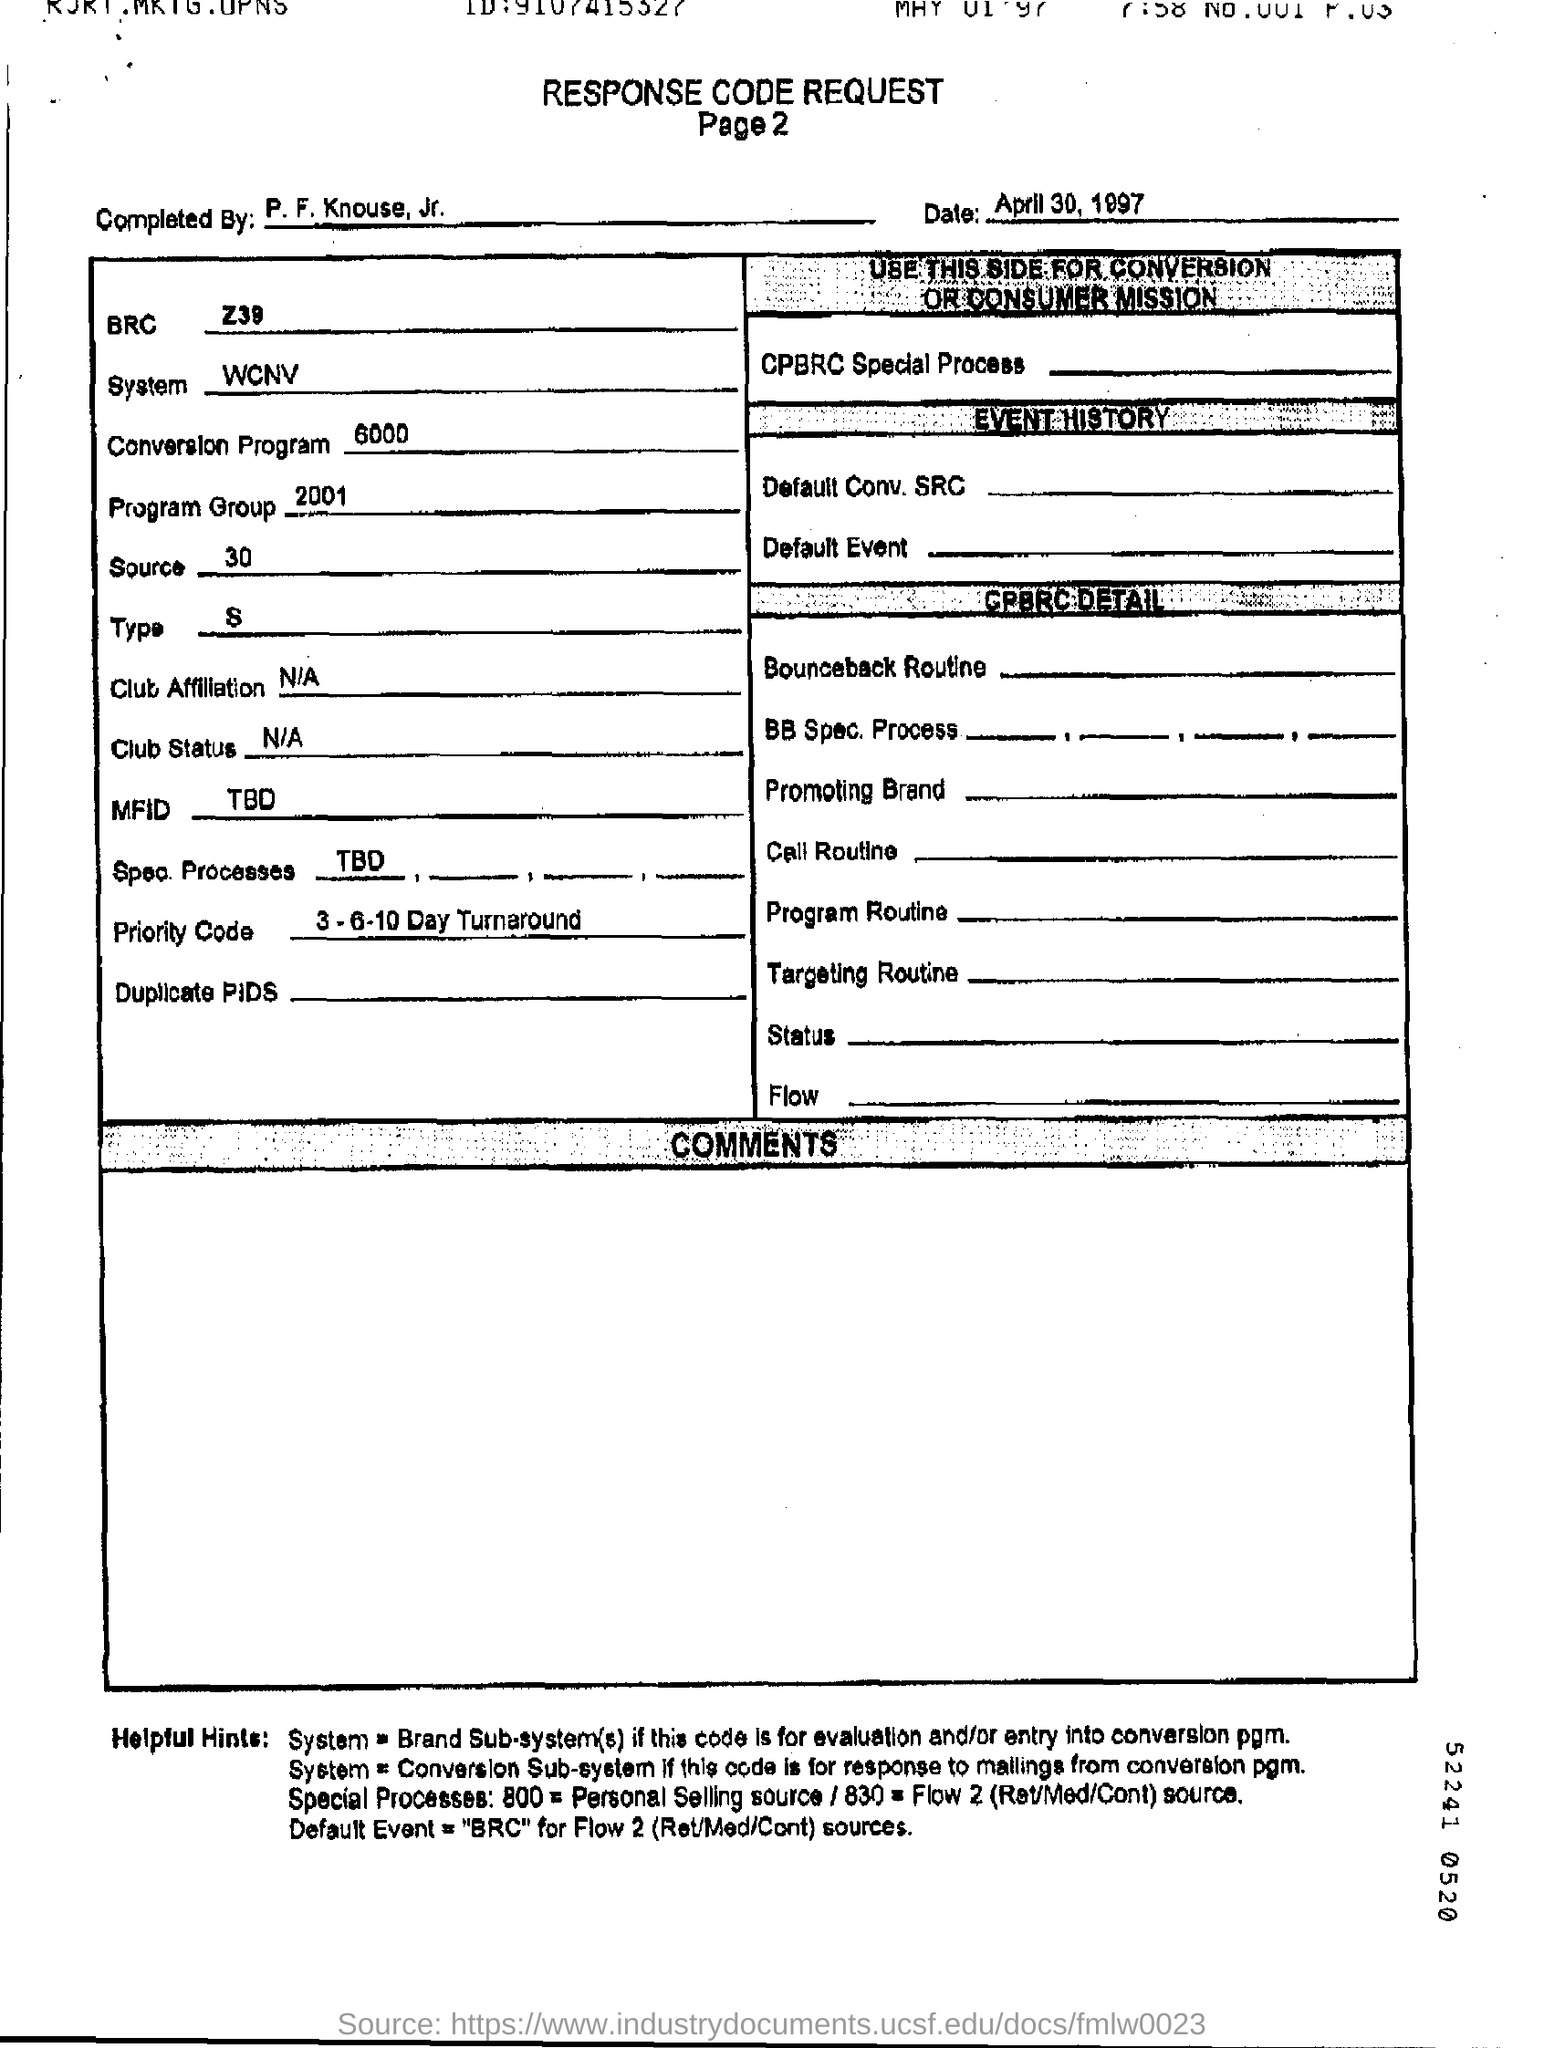Who is it completed by?
Your response must be concise. P. F. Knouse, Jr. What is the Date?
Provide a succinct answer. April 30, 1997. What is the BRC?
Give a very brief answer. Z39. What is the system?
Your answer should be very brief. WCNV. What is the Conversion program?
Offer a very short reply. 6000. What is the program group?
Make the answer very short. 2001. What is the source?
Keep it short and to the point. 30. What is the type?
Give a very brief answer. S. What is the Priority code?
Your answer should be compact. 3-6-10 Day Turnaround. What is the Title of the document?
Offer a very short reply. Response Code Request. 